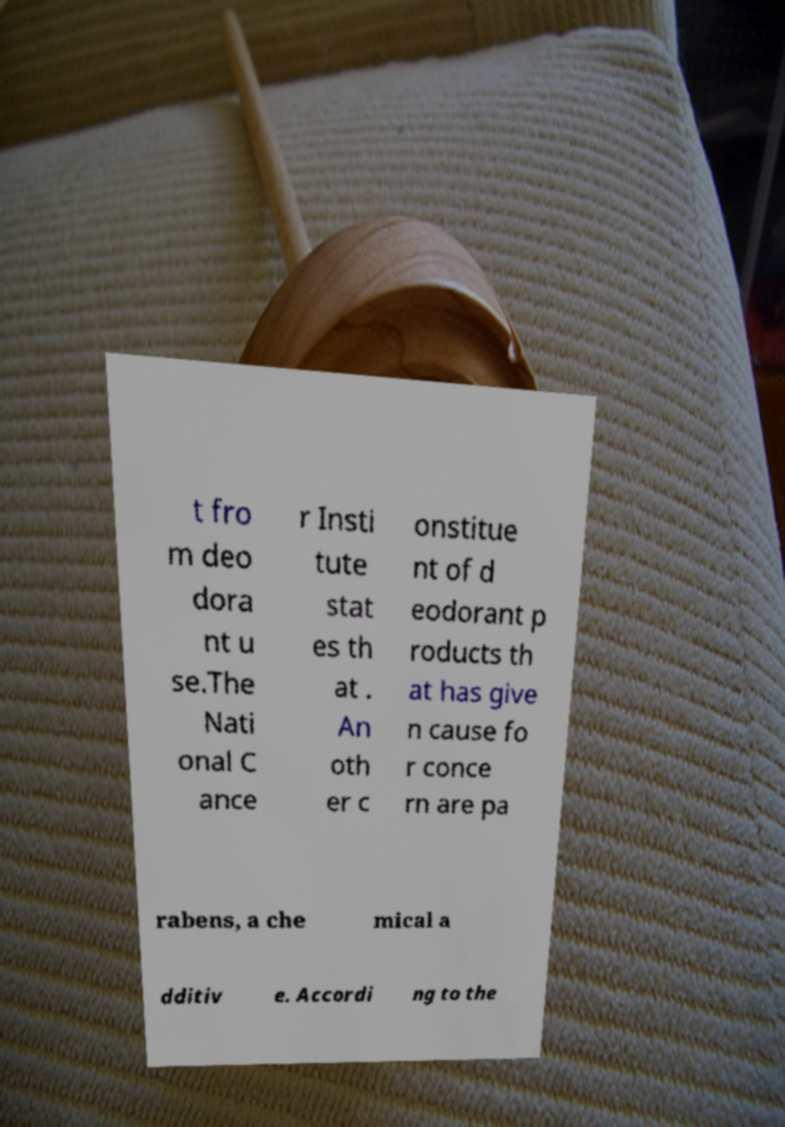I need the written content from this picture converted into text. Can you do that? t fro m deo dora nt u se.The Nati onal C ance r Insti tute stat es th at . An oth er c onstitue nt of d eodorant p roducts th at has give n cause fo r conce rn are pa rabens, a che mical a dditiv e. Accordi ng to the 